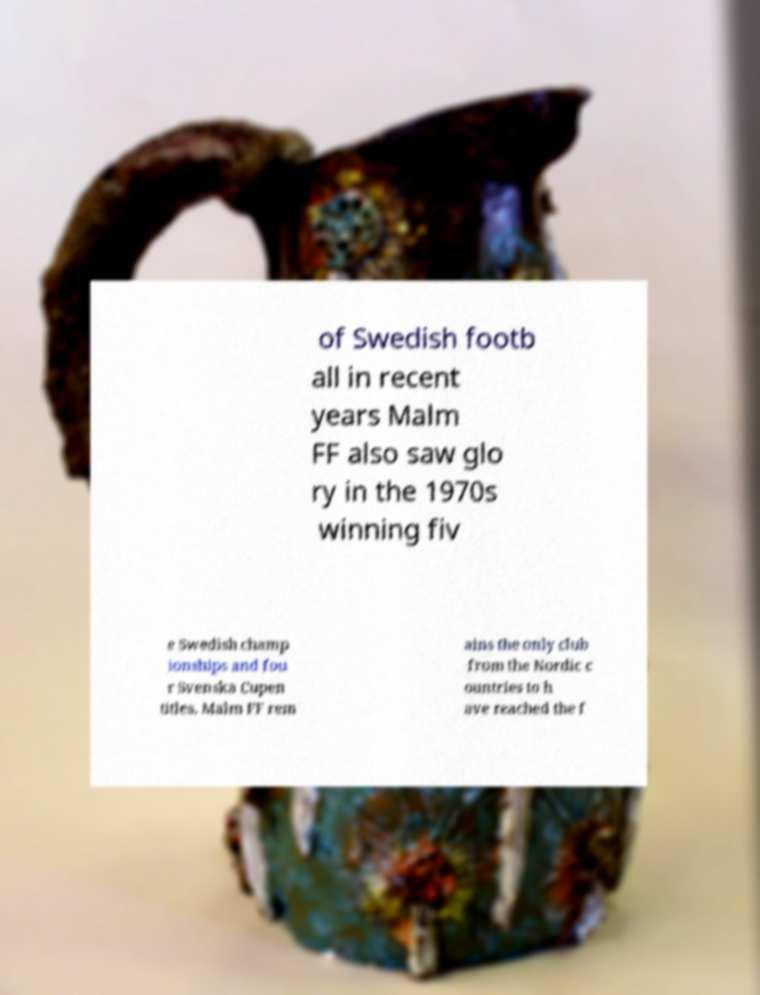There's text embedded in this image that I need extracted. Can you transcribe it verbatim? of Swedish footb all in recent years Malm FF also saw glo ry in the 1970s winning fiv e Swedish champ ionships and fou r Svenska Cupen titles. Malm FF rem ains the only club from the Nordic c ountries to h ave reached the f 